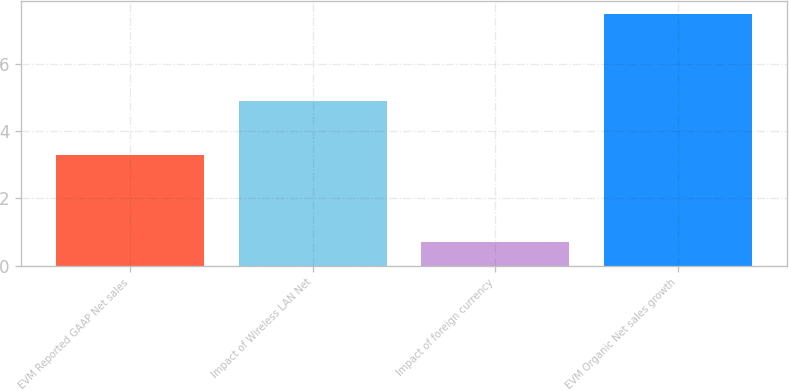<chart> <loc_0><loc_0><loc_500><loc_500><bar_chart><fcel>EVM Reported GAAP Net sales<fcel>Impact of Wireless LAN Net<fcel>Impact of foreign currency<fcel>EVM Organic Net sales growth<nl><fcel>3.3<fcel>4.9<fcel>0.7<fcel>7.5<nl></chart> 